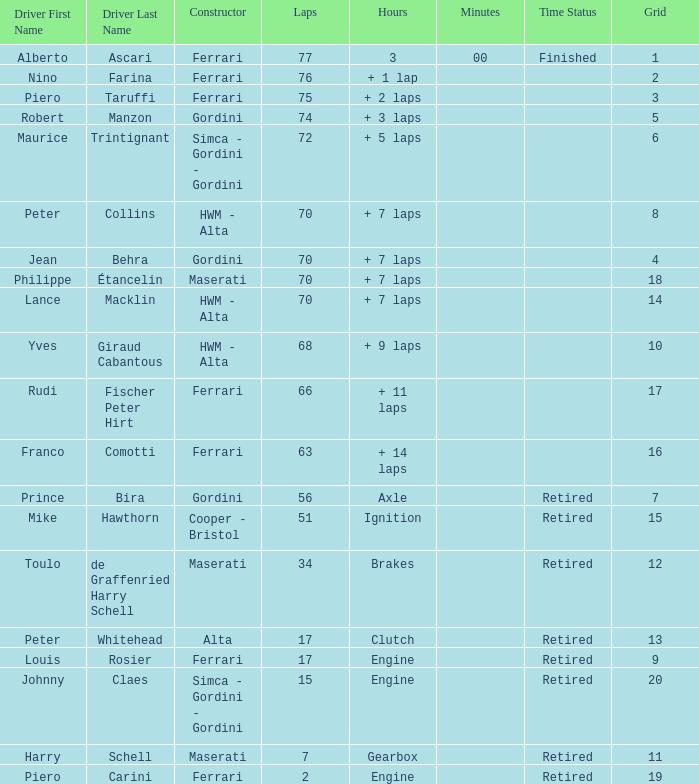Who drove the car with over 66 laps with a grid of 5? Robert Manzon. 